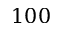Convert formula to latex. <formula><loc_0><loc_0><loc_500><loc_500>1 0 0</formula> 